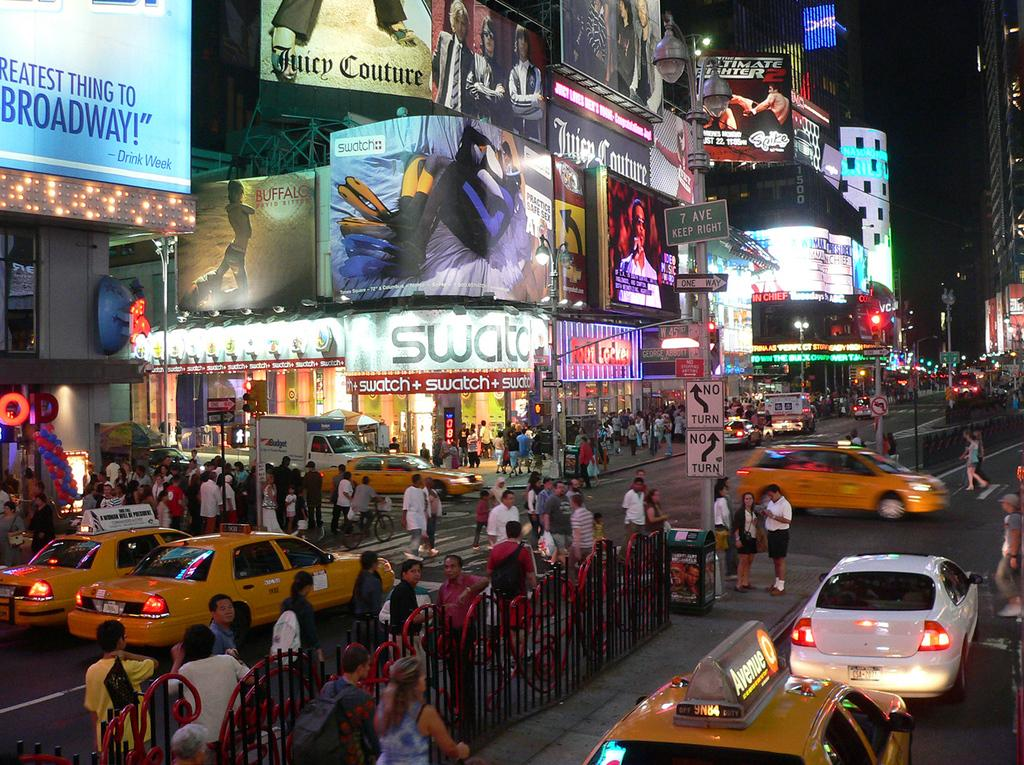Provide a one-sentence caption for the provided image. The store with the white sign is Swatch. 